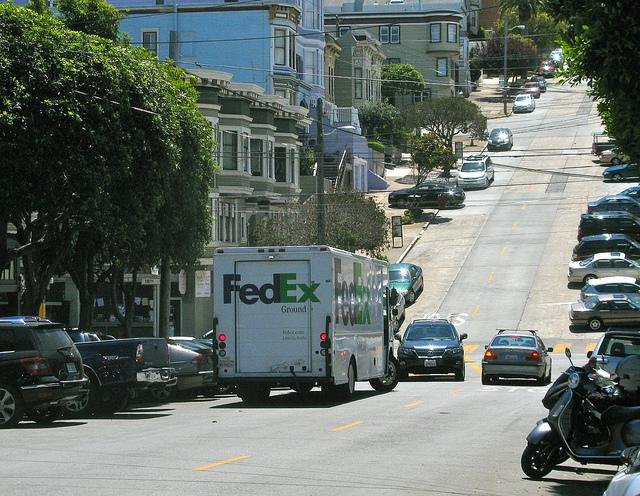Which car is in greatest danger if the FedEx car rushed forward?

Choices:
A) blue suv
B) silver sedan
C) motorcycle
D) black truck blue suv 